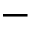Convert formula to latex. <formula><loc_0><loc_0><loc_500><loc_500>-</formula> 